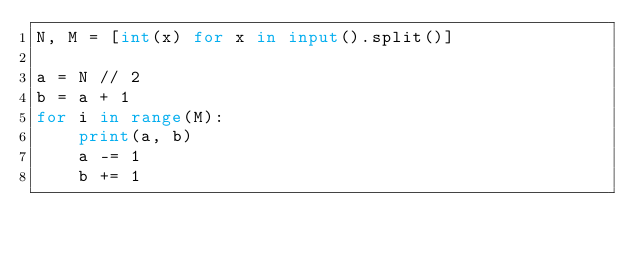<code> <loc_0><loc_0><loc_500><loc_500><_Python_>N, M = [int(x) for x in input().split()]

a = N // 2
b = a + 1
for i in range(M):
    print(a, b)
    a -= 1
    b += 1
</code> 